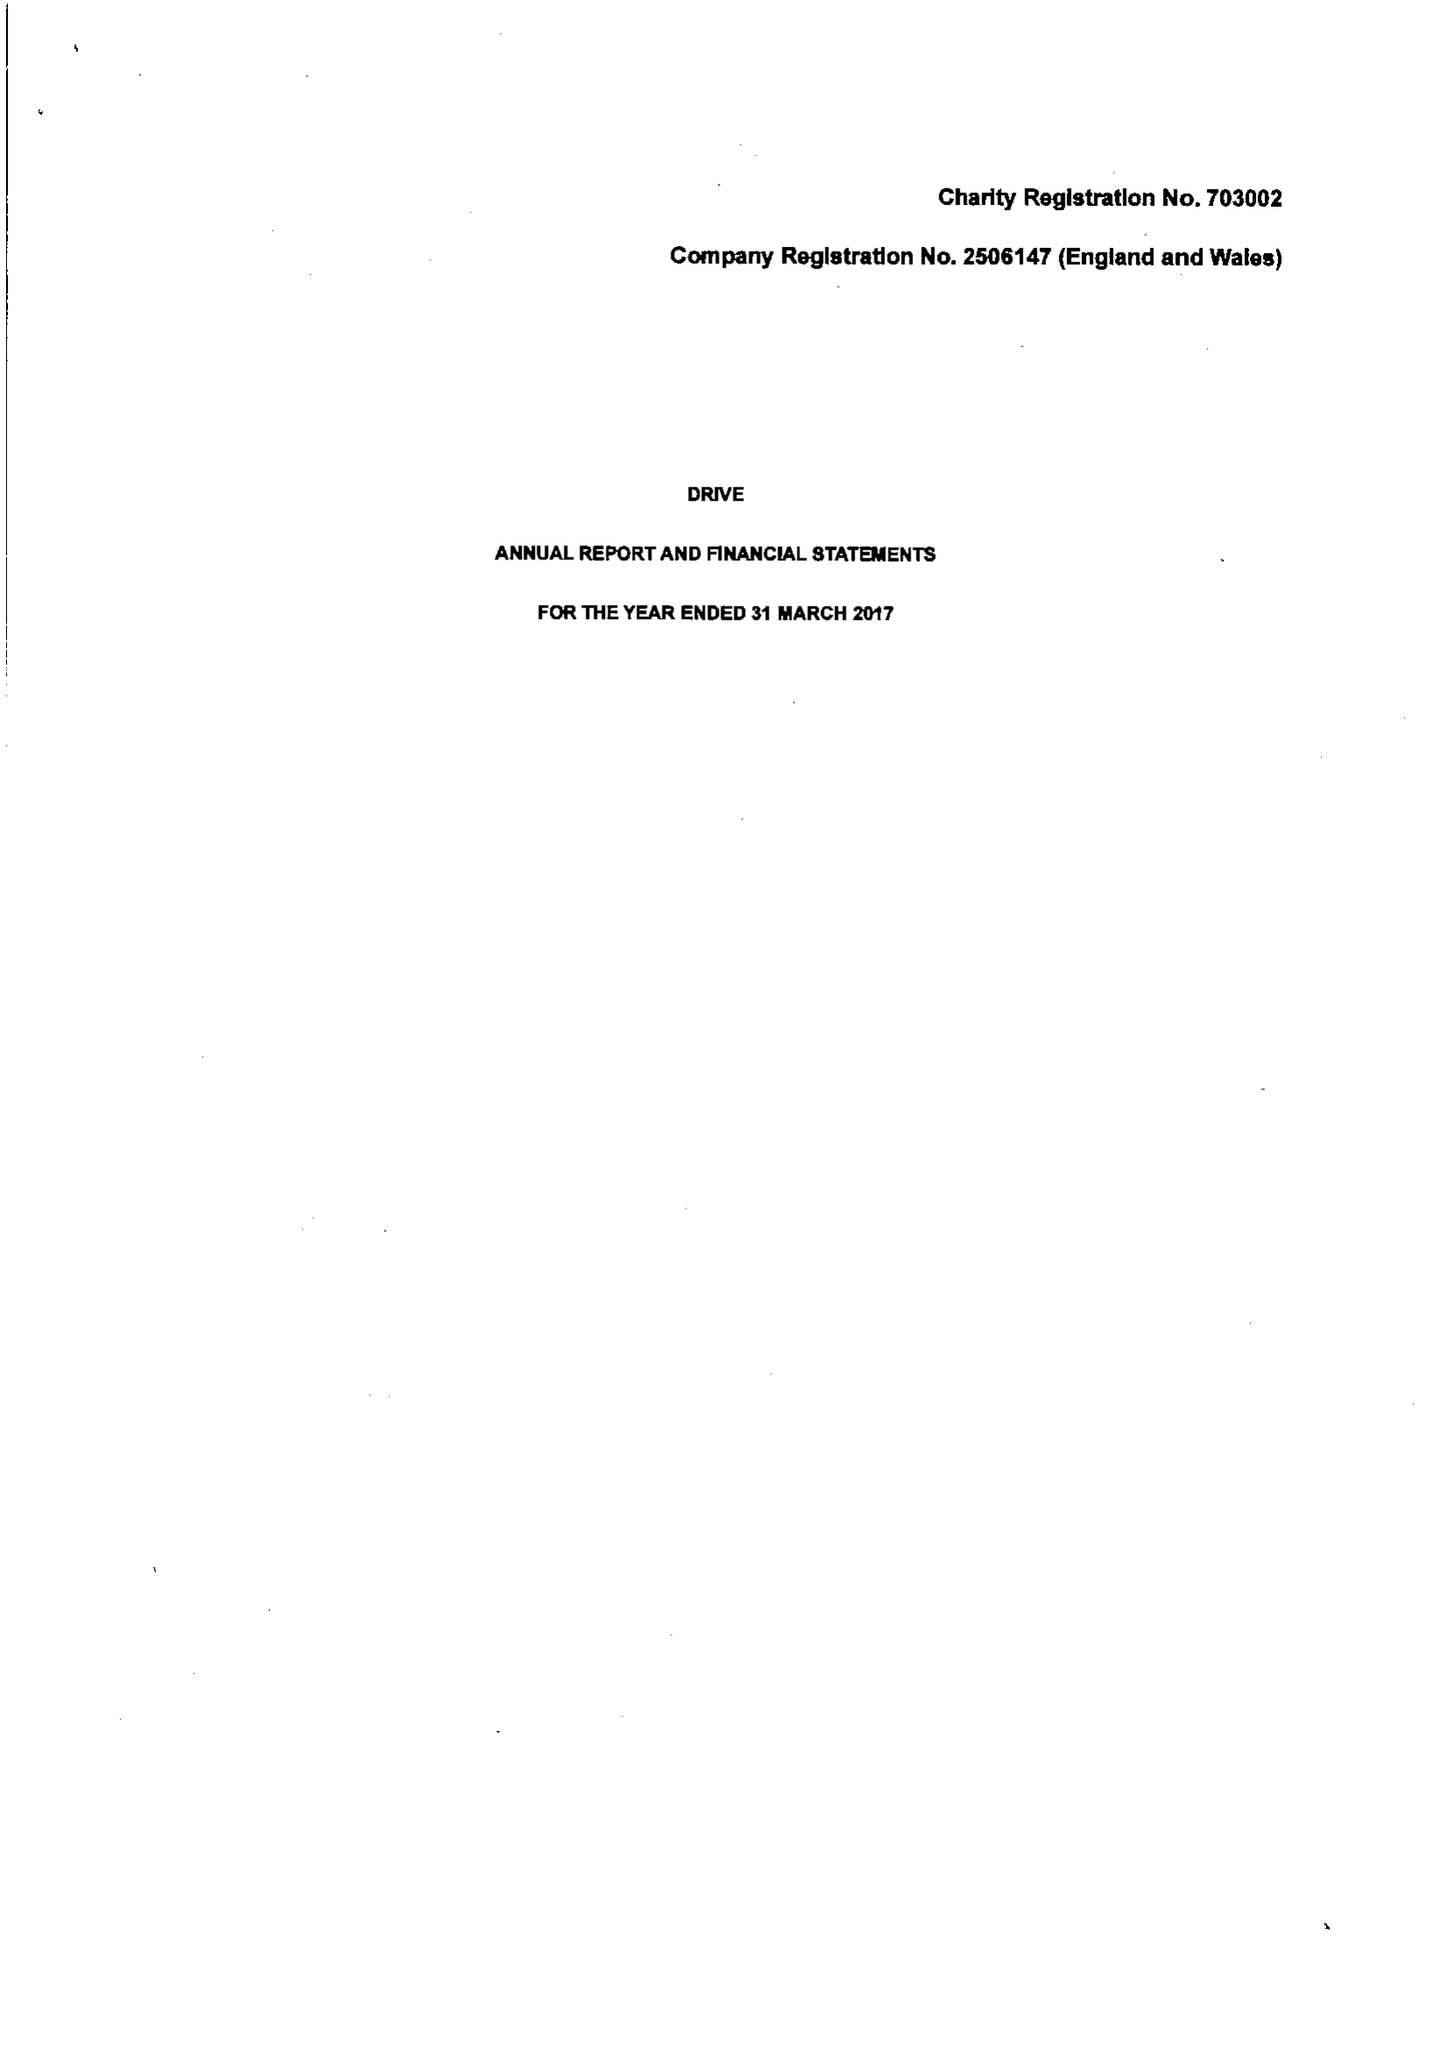What is the value for the income_annually_in_british_pounds?
Answer the question using a single word or phrase. 13505626.00 